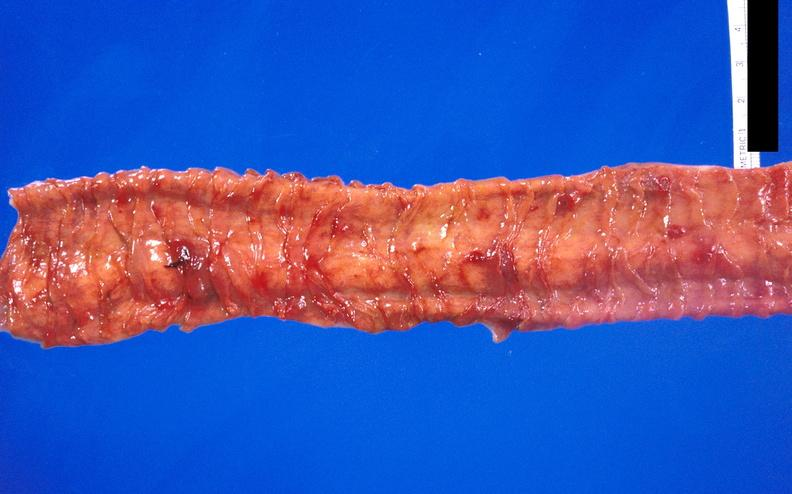does this image show hemorrhagic stress ulcers from patient with acute myelogenous leukemia?
Answer the question using a single word or phrase. Yes 